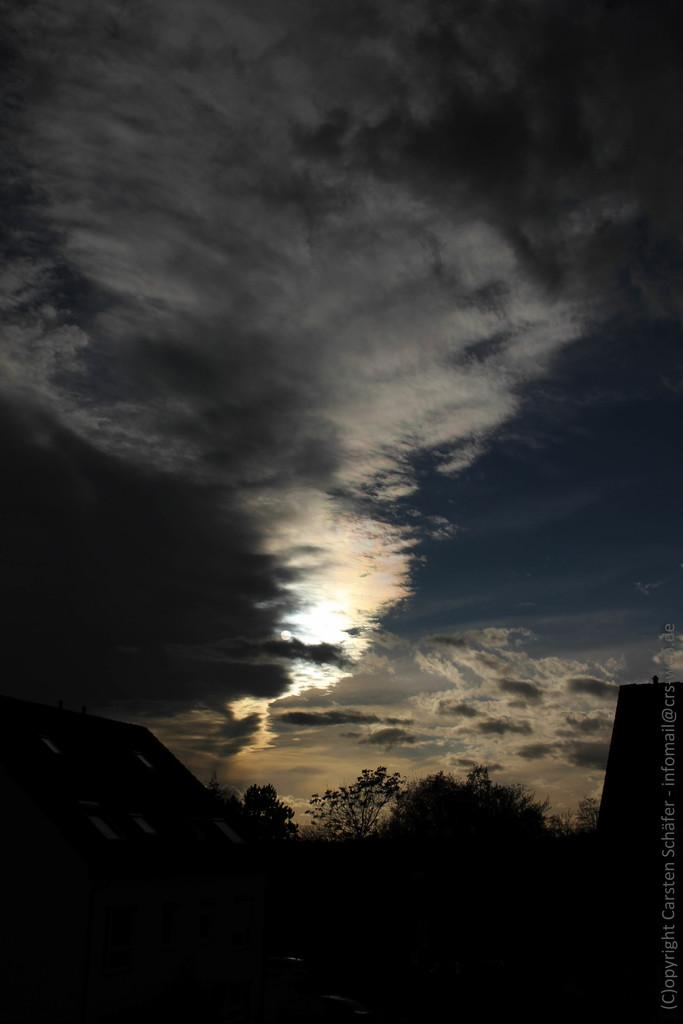What structures and natural elements are in the center of the image? There are trees and a house in the center of the image. What can be seen on the right side of the image? There is a watermark on the right side of the image. What is visible in the background of the image? The sky is visible in the background of the image. What type of weather can be inferred from the background of the image? Clouds are present in the background of the image, suggesting a partly cloudy day. What type of cable can be seen in the image? There is no cable visible in the image; it features trees, a house, a watermark, and clouds in the sky. What shape is the stream in the image? There is no stream present in the image. 